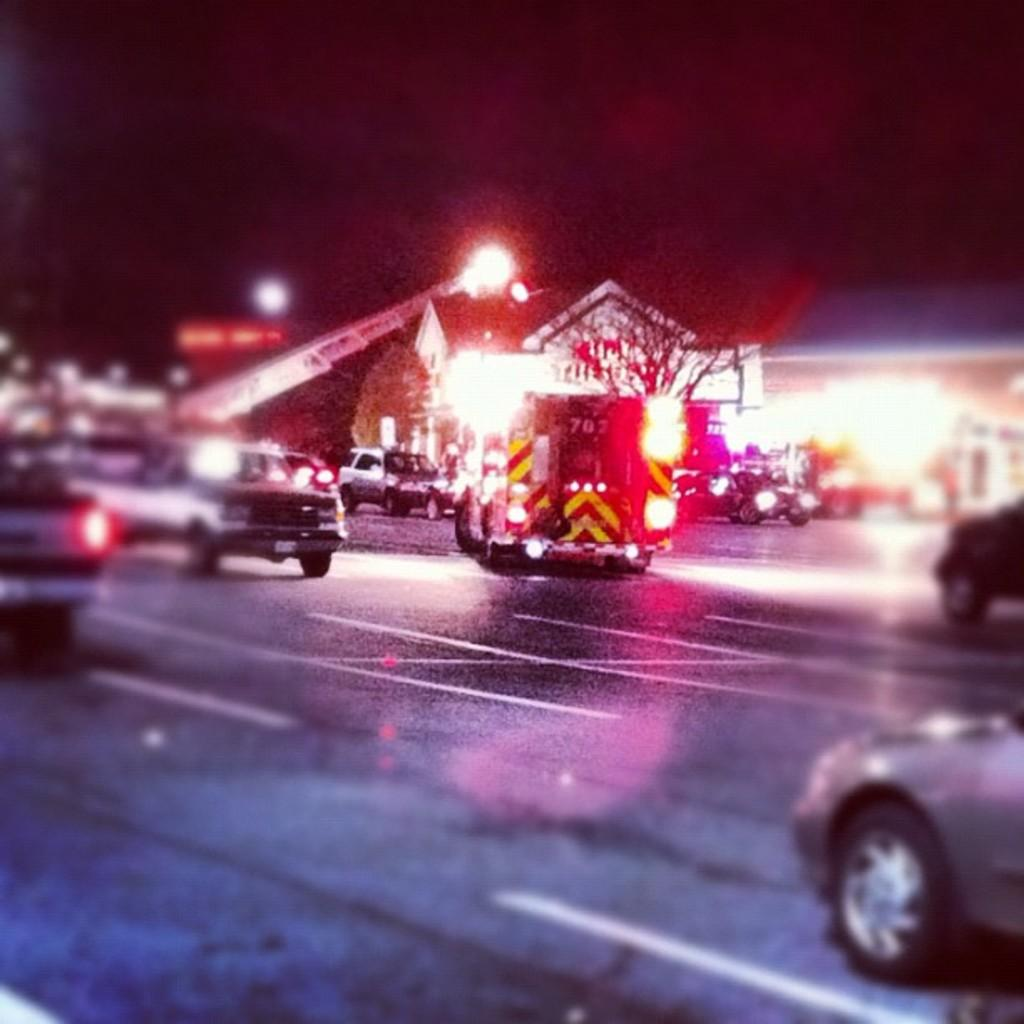What can be seen moving on the road in the image? There are vehicles on the road in the image. What is visible in the background of the image? There are buildings and trees in the background of the image. What type of construction equipment can be seen in the image? There is a crane visible in the image. What is visible at the top of the image? The sky is visible at the top of the image. What is present at the bottom of the image? There is a road at the bottom of the image. How many toes does the crane have in the image? Cranes are machines and do not have toes. The question is not relevant to the image. 